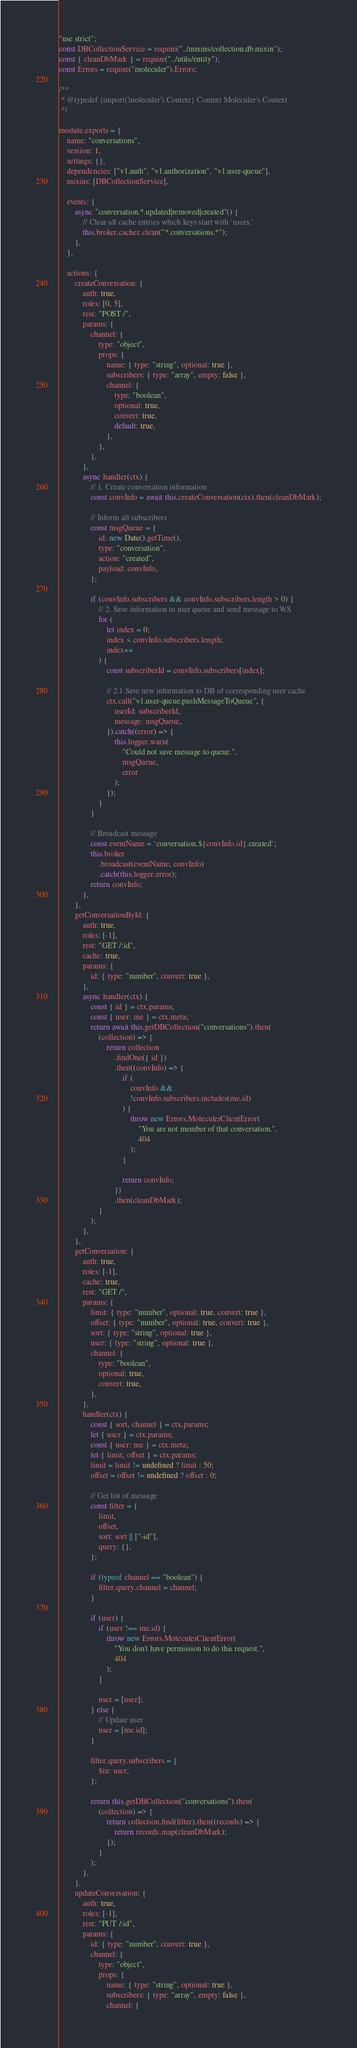Convert code to text. <code><loc_0><loc_0><loc_500><loc_500><_JavaScript_>"use strict";
const DBCollectionService = require("../mixins/collection.db.mixin");
const { cleanDbMark } = require("../utils/entity");
const Errors = require("moleculer").Errors;

/**
 * @typedef {import('moleculer').Context} Context Moleculer's Context
 */

module.exports = {
    name: "conversations",
    version: 1,
    settings: {},
    dependencies: ["v1.auth", "v1.authorization", "v1.user-queue"],
    mixins: [DBCollectionService],

    events: {
        async "conversation.*.updated|removed|created"() {
            // Clear all cache entries which keys start with `users.`
            this.broker.cacher.clean("*.conversations.*");
        },
    },

    actions: {
        createConversation: {
            auth: true,
            roles: [0, 5],
            rest: "POST /",
            params: {
                channel: {
                    type: "object",
                    props: {
                        name: { type: "string", optional: true },
                        subscribers: { type: "array", empty: false },
                        channel: {
                            type: "boolean",
                            optional: true,
                            convert: true,
                            default: true,
                        },
                    },
                },
            },
            async handler(ctx) {
                // 1. Create conversation information
                const convInfo = await this.createConversation(ctx).then(cleanDbMark);

                // Inform all subscribers
                const msgQueue = {
                    id: new Date().getTime(),
                    type: "conversation",
                    action: "created",
                    payload: convInfo,
                };

                if (convInfo.subscribers && convInfo.subscribers.length > 0) {
                    // 2. Save information to user queue and send message to WS
                    for (
                        let index = 0;
                        index < convInfo.subscribers.length;
                        index++
                    ) {
                        const subscriberId = convInfo.subscribers[index];

                        // 2.1 Save new information to DB of corresponding user cache
                        ctx.call("v1.user-queue.pushMessageToQueue", {
                            userId: subscriberId,
                            message: msgQueue,
                        }).catch((error) => {
                            this.logger.warn(
                                "Could not save message to queue.",
                                msgQueue,
                                error
                            );
                        });
                    }
                }

                // Broadcast message
                const eventName = `conversation.${convInfo.id}.created`;
                this.broker
                    .broadcast(eventName, convInfo)
                    .catch(this.logger.error);
                return convInfo;
            },
        },
        getConversationById: {
            auth: true,
            roles: [-1],
            rest: "GET /:id",
            cache: true,
            params: {
                id: { type: "number", convert: true },
            },
            async handler(ctx) {
                const { id } = ctx.params;
                const { user: me } = ctx.meta;
                return await this.getDBCollection("conversations").then(
                    (collection) => {
                        return collection
                            .findOne({ id })
                            .then((convInfo) => {
                                if (
                                    convInfo &&
                                    !convInfo.subscribers.includes(me.id)
                                ) {
                                    throw new Errors.MoleculerClientError(
                                        "You are not member of that conversation.",
                                        404
                                    );
                                }

                                return convInfo;
                            })
                            .then(cleanDbMark);
                    }
                );
            },
        },
        getConversation: {
            auth: true,
            roles: [-1],
            cache: true,
            rest: "GET /",
            params: {
                limit: { type: "number", optional: true, convert: true },
                offset: { type: "number", optional: true, convert: true },
                sort: { type: "string", optional: true },
                user: { type: "string", optional: true },
                channel: {
                    type: "boolean",
                    optional: true,
                    convert: true,
                },
            },
            handler(ctx) {
                const { sort, channel } = ctx.params;
                let { user } = ctx.params;
                const { user: me } = ctx.meta;
                let { limit, offset } = ctx.params;
                limit = limit != undefined ? limit : 50;
                offset = offset != undefined ? offset : 0;

                // Get list of message
                const filter = {
                    limit,
                    offset,
                    sort: sort || ["-id"],
                    query: {},
                };

                if (typeof channel == "boolean") {
                    filter.query.channel = channel;
                }

                if (user) {
                    if (user !== me.id) {
                        throw new Errors.MoleculerClientError(
                            "You don't have permission to do this request.",
                            404
                        );
                    }

                    user = [user];
                } else {
                    // Update user
                    user = [me.id];
                }

                filter.query.subscribers = {
                    $in: user,
                };

                return this.getDBCollection("conversations").then(
                    (collection) => {
                        return collection.find(filter).then((records) => {
                            return records.map(cleanDbMark);
                        });
                    }
                );
            },
        },
        updateConversation: {
            auth: true,
            roles: [-1],
            rest: "PUT /:id",
            params: {
                id: { type: "number", convert: true },
                channel: {
                    type: "object",
                    props: {
                        name: { type: "string", optional: true },
                        subscribers: { type: "array", empty: false },
                        channel: {</code> 